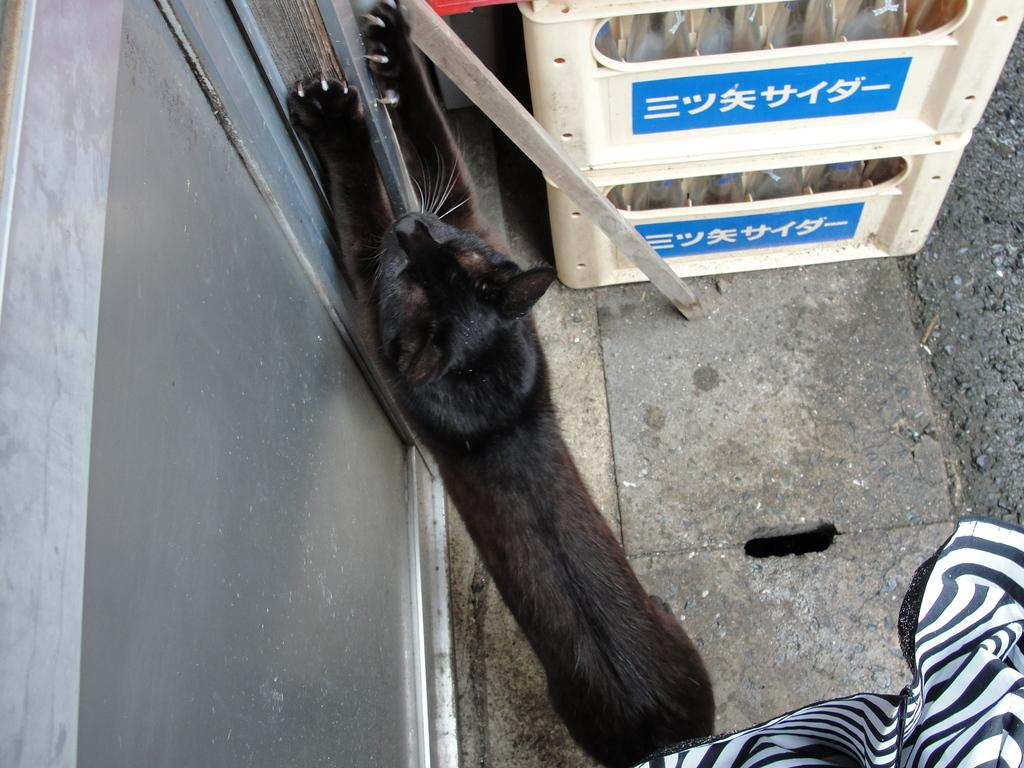What type of animal is in the image? There is a black animal in the image. Where is the animal located? The animal is on a path. What objects are in front of the animal? There are plastic containers in front of the animal. What can be seen on the left side of the animal? There appears to be a door on the left side of the animal. What verse is the animal reciting in the image? There is no indication in the image that the animal is reciting a verse, as animals do not have the ability to speak or recite poetry. 